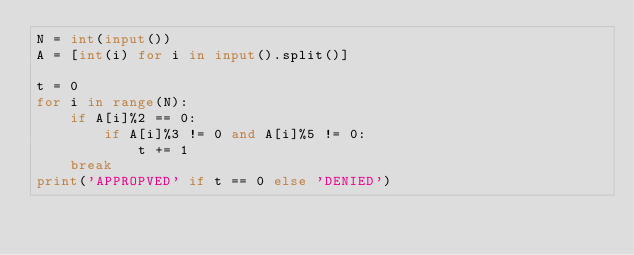<code> <loc_0><loc_0><loc_500><loc_500><_Python_>N = int(input())
A = [int(i) for i in input().split()]

t = 0
for i in range(N):
    if A[i]%2 == 0:
        if A[i]%3 != 0 and A[i]%5 != 0:
            t += 1
    break
print('APPROPVED' if t == 0 else 'DENIED')</code> 